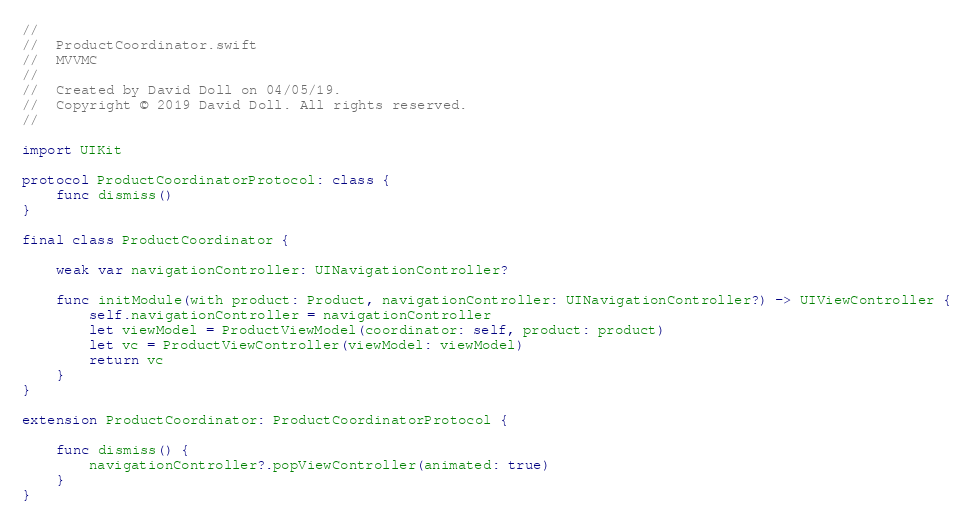Convert code to text. <code><loc_0><loc_0><loc_500><loc_500><_Swift_>//
//  ProductCoordinator.swift
//  MVVMC
//
//  Created by David Doll on 04/05/19.
//  Copyright © 2019 David Doll. All rights reserved.
//

import UIKit

protocol ProductCoordinatorProtocol: class {
    func dismiss()
}

final class ProductCoordinator {
    
    weak var navigationController: UINavigationController?
    
    func initModule(with product: Product, navigationController: UINavigationController?) -> UIViewController {
        self.navigationController = navigationController
        let viewModel = ProductViewModel(coordinator: self, product: product)
        let vc = ProductViewController(viewModel: viewModel)
        return vc
    }
}

extension ProductCoordinator: ProductCoordinatorProtocol {
    
    func dismiss() {
        navigationController?.popViewController(animated: true)
    }
}
</code> 